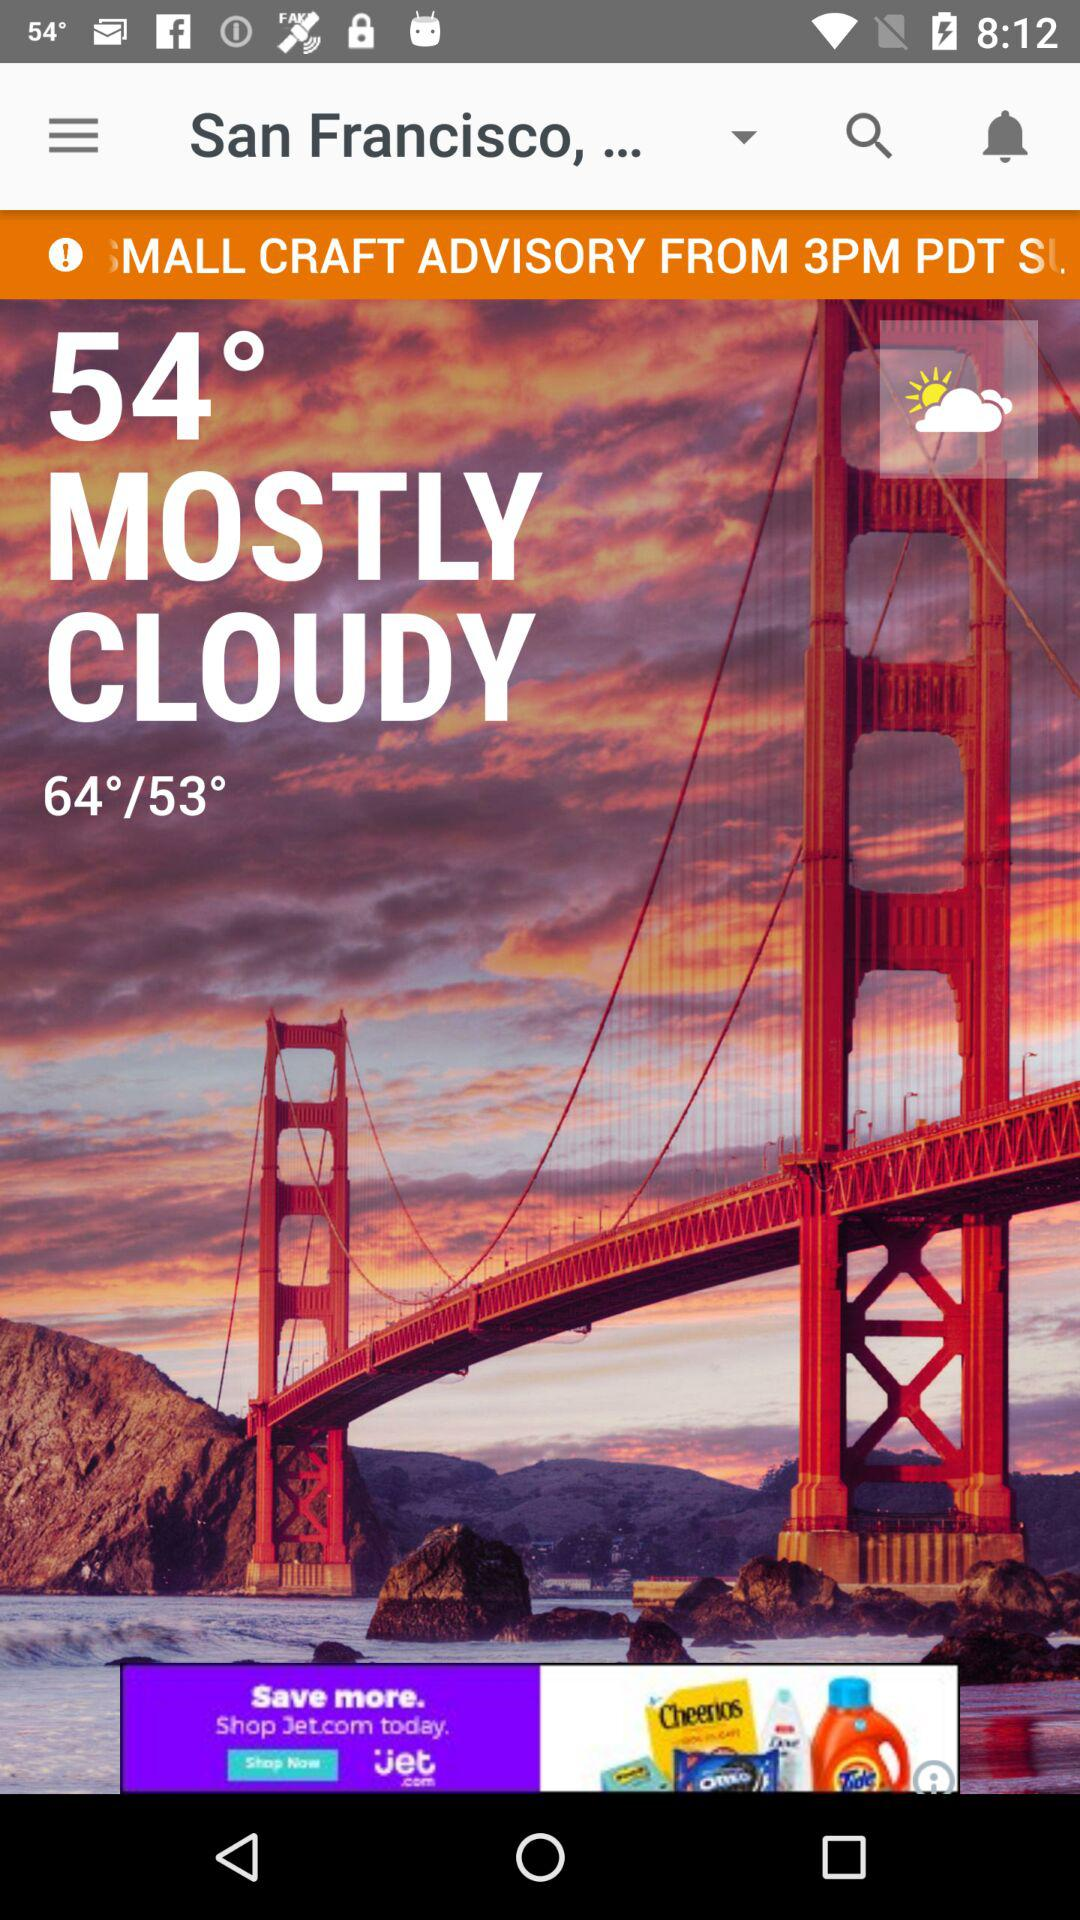How many more degrees is the high temperature than the current temperature?
Answer the question using a single word or phrase. 10 